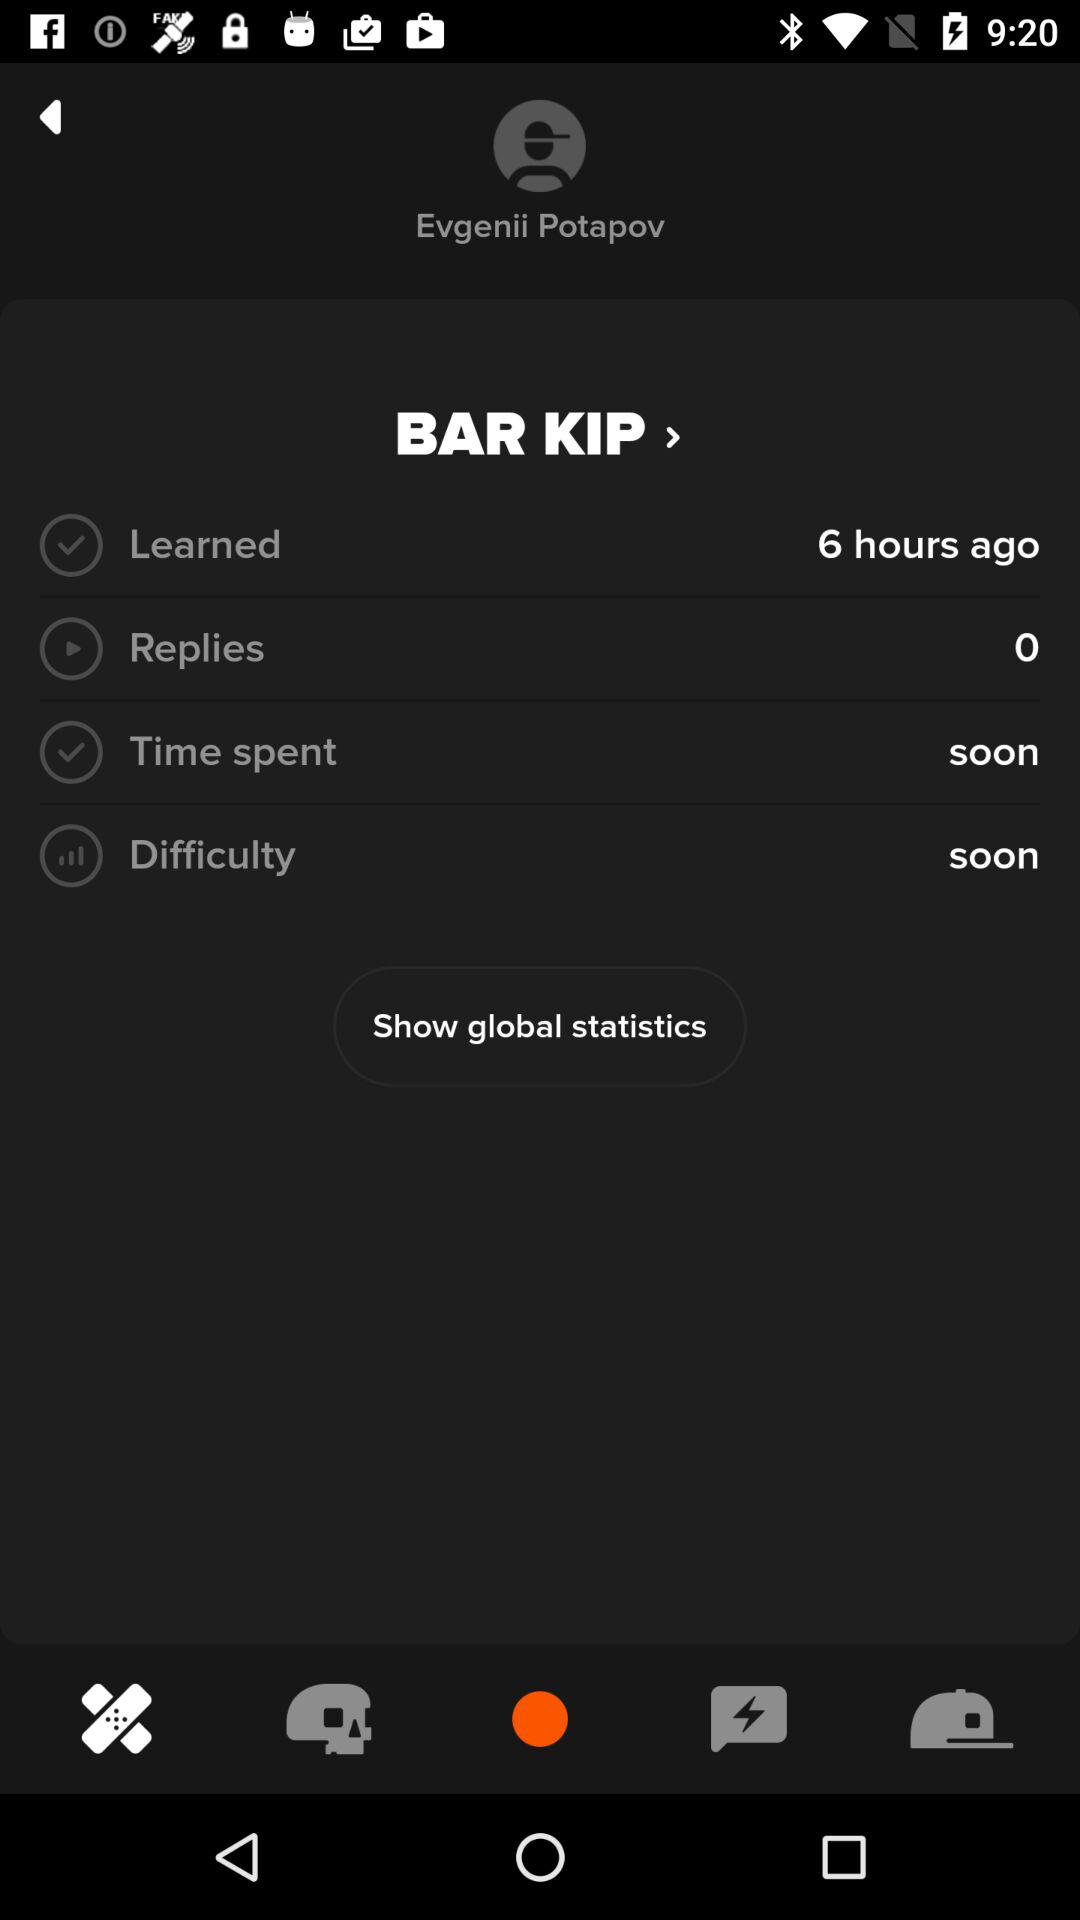What is the user name? The user name is Evgenii Potapov. 